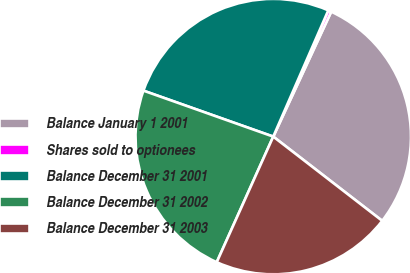Convert chart to OTSL. <chart><loc_0><loc_0><loc_500><loc_500><pie_chart><fcel>Balance January 1 2001<fcel>Shares sold to optionees<fcel>Balance December 31 2001<fcel>Balance December 31 2002<fcel>Balance December 31 2003<nl><fcel>28.56%<fcel>0.37%<fcel>26.13%<fcel>23.69%<fcel>21.26%<nl></chart> 